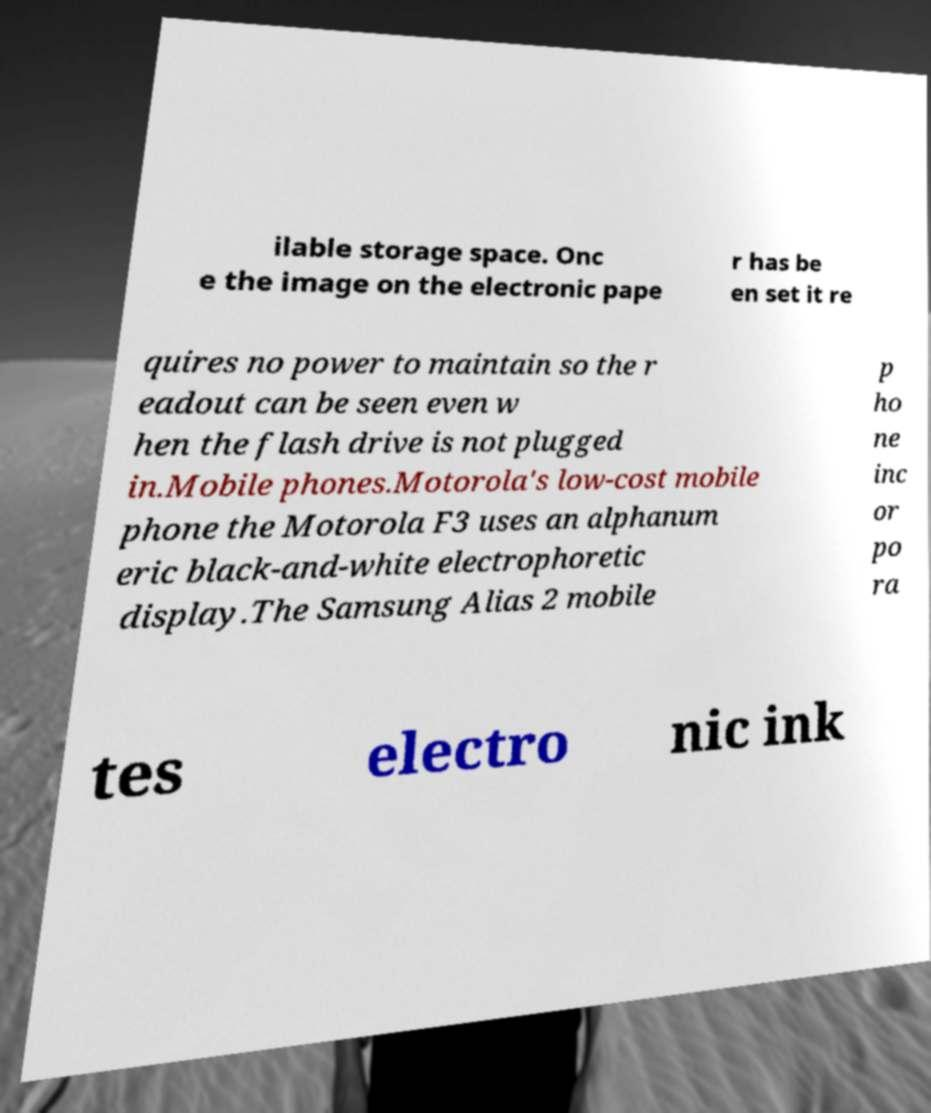Can you read and provide the text displayed in the image?This photo seems to have some interesting text. Can you extract and type it out for me? ilable storage space. Onc e the image on the electronic pape r has be en set it re quires no power to maintain so the r eadout can be seen even w hen the flash drive is not plugged in.Mobile phones.Motorola's low-cost mobile phone the Motorola F3 uses an alphanum eric black-and-white electrophoretic display.The Samsung Alias 2 mobile p ho ne inc or po ra tes electro nic ink 